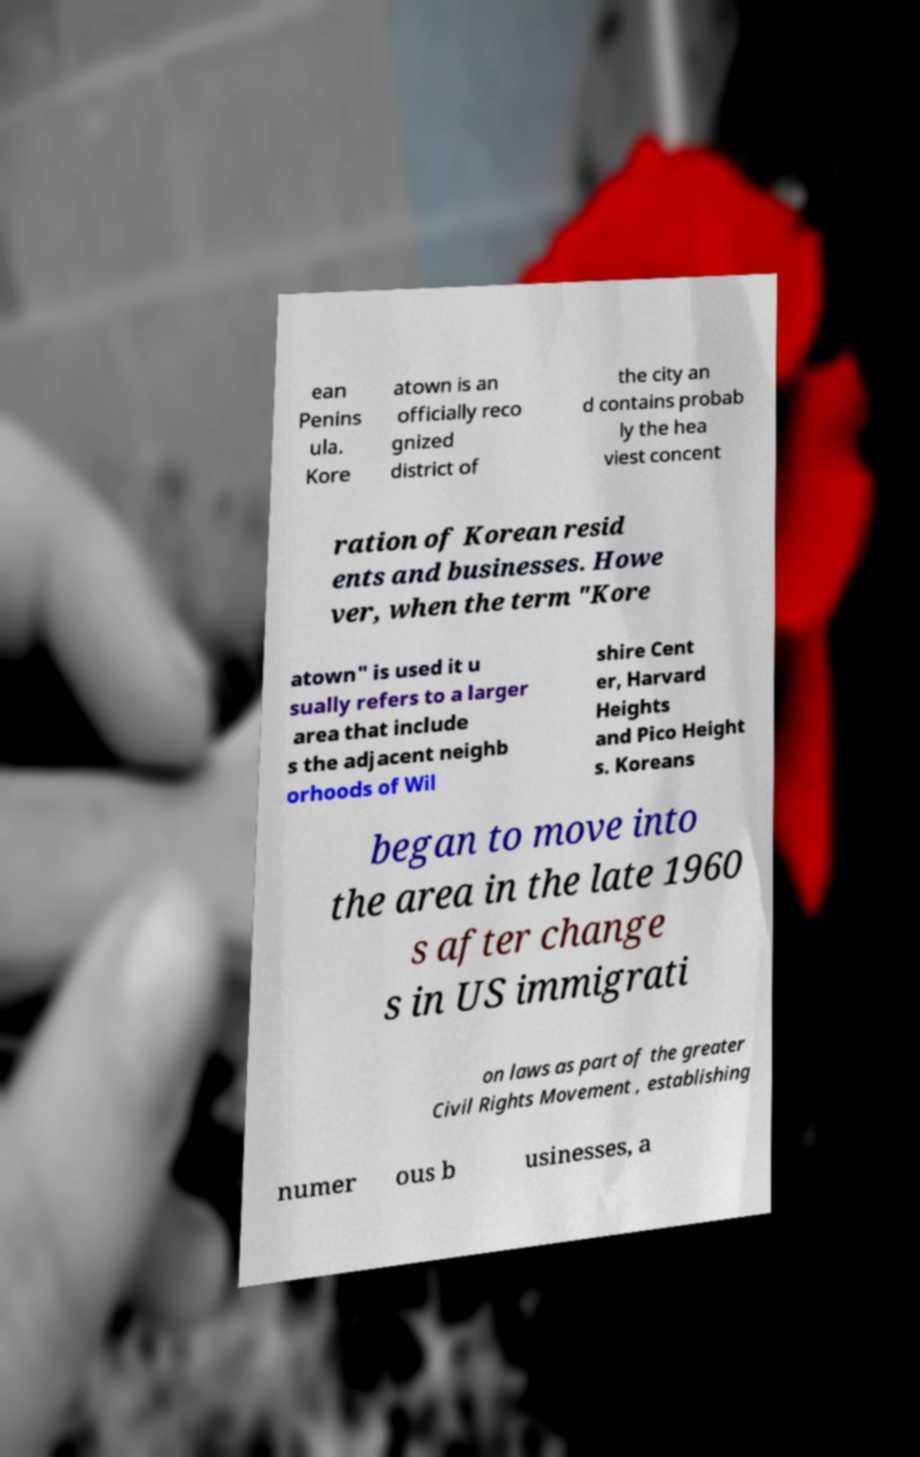There's text embedded in this image that I need extracted. Can you transcribe it verbatim? ean Penins ula. Kore atown is an officially reco gnized district of the city an d contains probab ly the hea viest concent ration of Korean resid ents and businesses. Howe ver, when the term "Kore atown" is used it u sually refers to a larger area that include s the adjacent neighb orhoods of Wil shire Cent er, Harvard Heights and Pico Height s. Koreans began to move into the area in the late 1960 s after change s in US immigrati on laws as part of the greater Civil Rights Movement , establishing numer ous b usinesses, a 